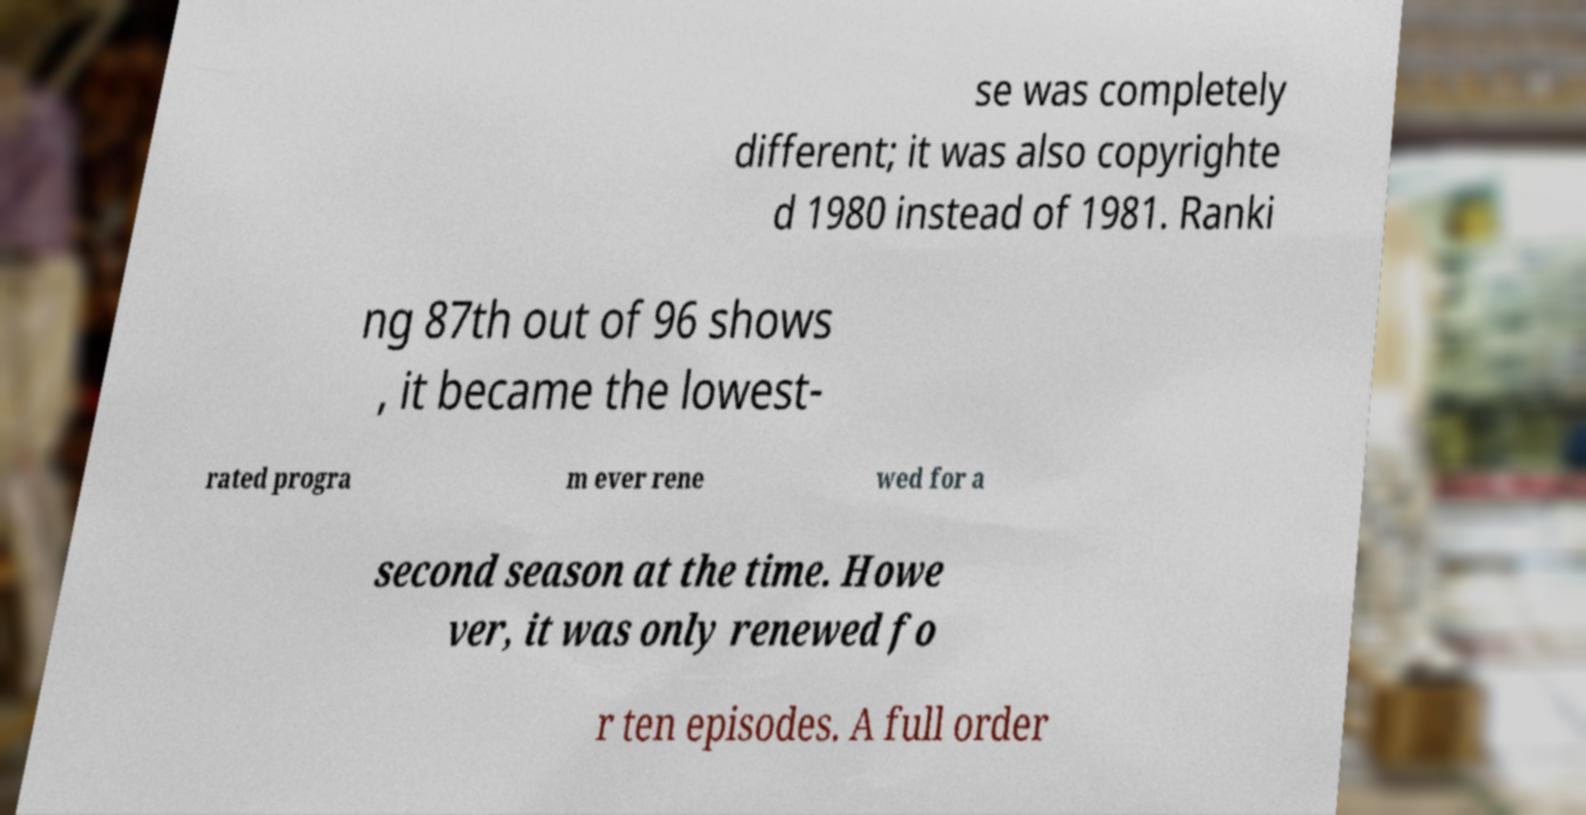What messages or text are displayed in this image? I need them in a readable, typed format. se was completely different; it was also copyrighte d 1980 instead of 1981. Ranki ng 87th out of 96 shows , it became the lowest- rated progra m ever rene wed for a second season at the time. Howe ver, it was only renewed fo r ten episodes. A full order 